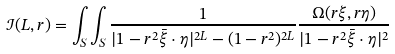<formula> <loc_0><loc_0><loc_500><loc_500>\mathcal { I } ( L , r ) = \int _ { S } \int _ { S } \frac { 1 } { | 1 - r ^ { 2 } \bar { \xi } \cdot \eta | ^ { 2 L } - ( 1 - r ^ { 2 } ) ^ { 2 L } } \frac { \Omega ( r \xi , r \eta ) } { | 1 - r ^ { 2 } \bar { \xi } \cdot \eta | ^ { 2 } }</formula> 